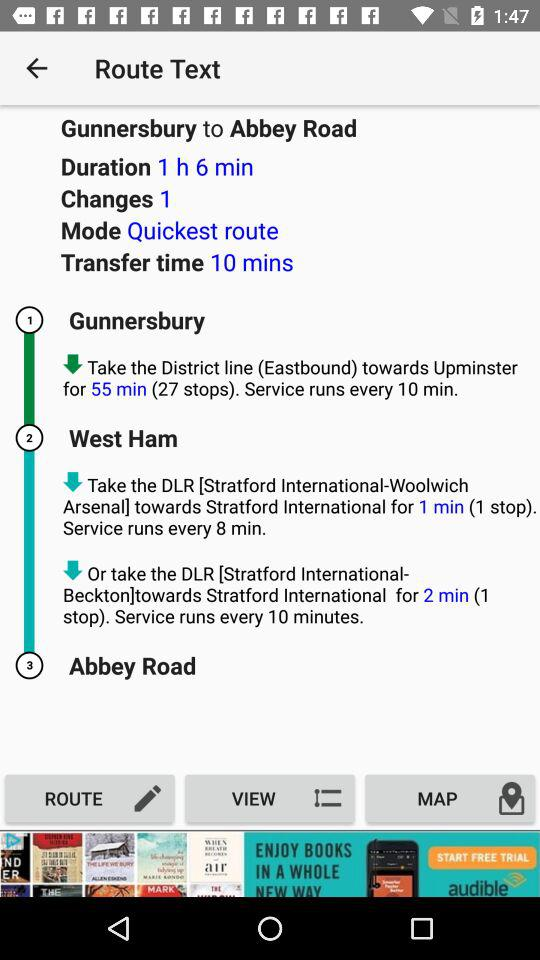How long is the transfer time?
Answer the question using a single word or phrase. 10 mins 